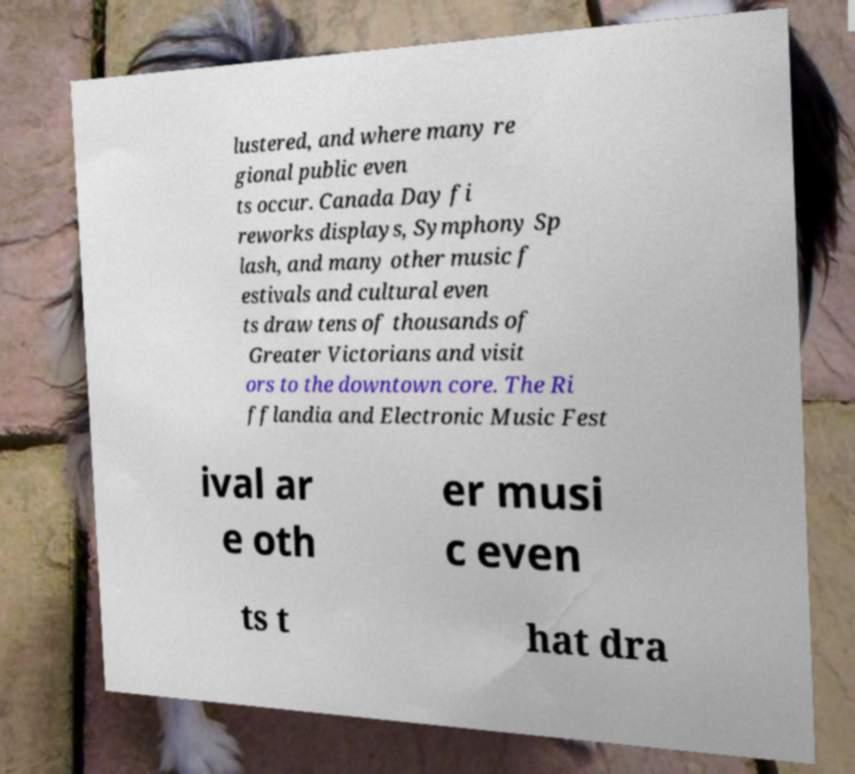Please read and relay the text visible in this image. What does it say? lustered, and where many re gional public even ts occur. Canada Day fi reworks displays, Symphony Sp lash, and many other music f estivals and cultural even ts draw tens of thousands of Greater Victorians and visit ors to the downtown core. The Ri fflandia and Electronic Music Fest ival ar e oth er musi c even ts t hat dra 